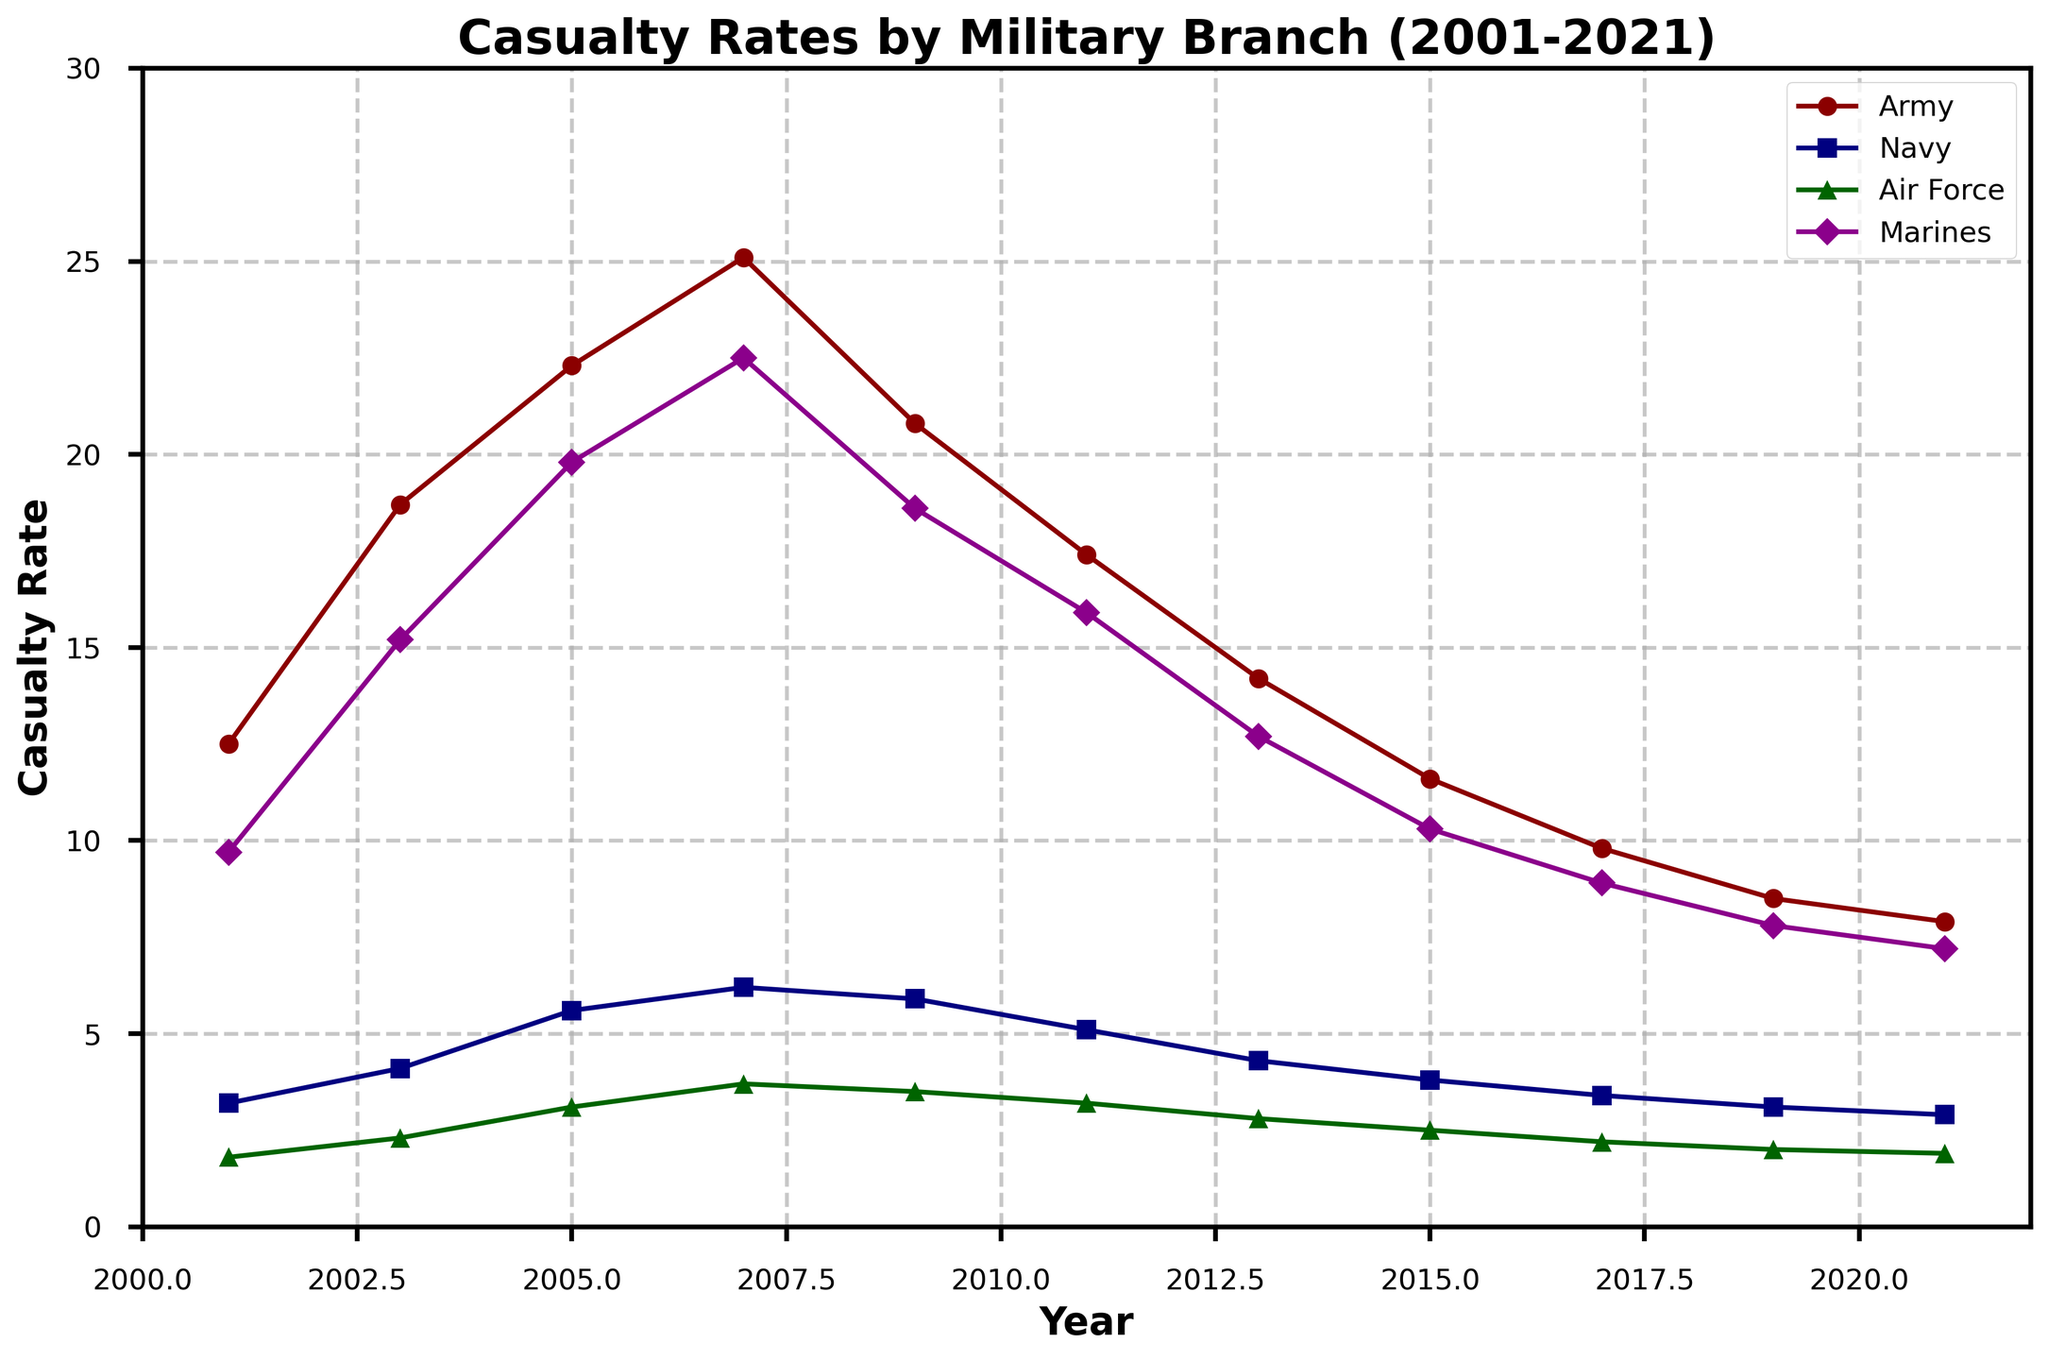What is the general trend in casualty rates for the Army from 2001 to 2021? The Army's casualty rates peaked around 2007 and have gradually declined since then. By observing the figure, one can see a rise from 2001 to 2007, followed by a steady decrease to 2021.
Answer: Declining Which military branch had the lowest casualty rate in 2015? By inspecting the data points on the line chart for 2015, it is clear that the Air Force had the lowest casualty rate compared to the Army, Navy, and Marines.
Answer: Air Force In what year did the Navy experience its highest casualty rate, and what is the rate? By checking the peaks of the Navy's line on the graph, the highest point appears to be in 2007. Referring to the data, the rate is 6.2.
Answer: 2007, 6.2 Which conflict type showed the highest casualty rate in any year, and what was the rate? By looking at the highest peaks of each conflict type line, Counter-Insurgency in 2007 had the highest rate. Then, checking the data confirms it was 33.9.
Answer: Counter-Insurgency, 33.9 How did the casualty rate for Marines change between 2009 and 2017? The Marines' casualty rate went from 18.6 in 2009 downward to 8.9 in 2017 as seen by following the corresponding line on the graph.
Answer: Decreased What is the difference in casualty rates between Conventional War and Peacekeeping in 2011? The Conventional War rate in 2011 was 7.5, while the Peacekeeping rate was 1.6. The difference is calculated by 7.5 - 1.6.
Answer: 5.9 Between which years did the Army see the most significant drop in casualty rates? By observing the steepest downward slope on the Army line, the largest drop occurs between 2007 and 2009. In this time frame, the rate dropped from 25.1 to 20.8.
Answer: 2007-2009 Which branch had a consistently higher casualty rate than the Navy from 2001 to 2021? By comparing all the branch lines over the years, the Army and Marines consistently have higher rates than the Navy in every year.
Answer: Army and Marines 